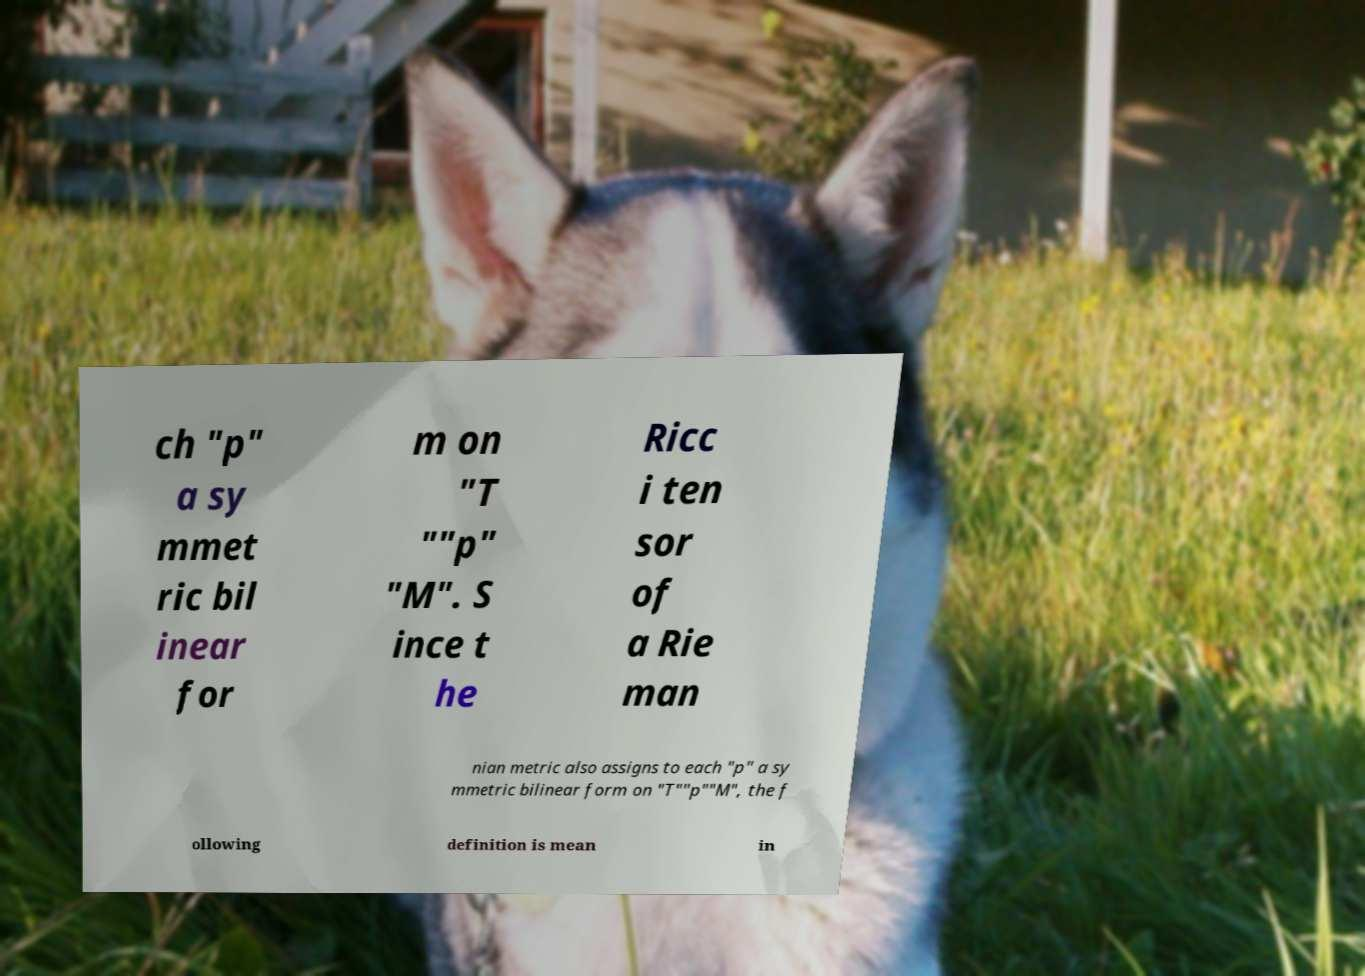Could you assist in decoding the text presented in this image and type it out clearly? ch "p" a sy mmet ric bil inear for m on "T ""p" "M". S ince t he Ricc i ten sor of a Rie man nian metric also assigns to each "p" a sy mmetric bilinear form on "T""p""M", the f ollowing definition is mean in 